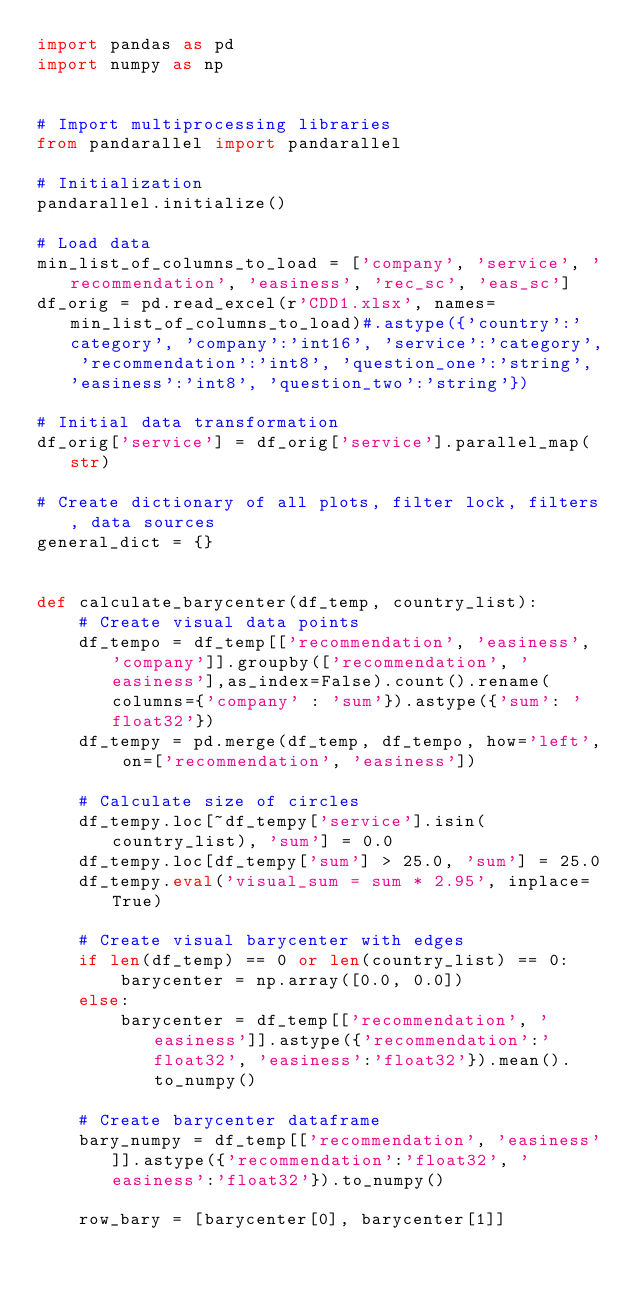Convert code to text. <code><loc_0><loc_0><loc_500><loc_500><_Python_>import pandas as pd
import numpy as np


# Import multiprocessing libraries
from pandarallel import pandarallel

# Initialization
pandarallel.initialize()

# Load data
min_list_of_columns_to_load = ['company', 'service', 'recommendation', 'easiness', 'rec_sc', 'eas_sc']
df_orig = pd.read_excel(r'CDD1.xlsx', names=min_list_of_columns_to_load)#.astype({'country':'category', 'company':'int16', 'service':'category', 'recommendation':'int8', 'question_one':'string', 'easiness':'int8', 'question_two':'string'})

# Initial data transformation
df_orig['service'] = df_orig['service'].parallel_map(str)

# Create dictionary of all plots, filter lock, filters, data sources
general_dict = {}


def calculate_barycenter(df_temp, country_list):   
    # Create visual data points
    df_tempo = df_temp[['recommendation', 'easiness', 'company']].groupby(['recommendation', 'easiness'],as_index=False).count().rename(columns={'company' : 'sum'}).astype({'sum': 'float32'})
    df_tempy = pd.merge(df_temp, df_tempo, how='left', on=['recommendation', 'easiness'])

    # Calculate size of circles
    df_tempy.loc[~df_tempy['service'].isin(country_list), 'sum'] = 0.0
    df_tempy.loc[df_tempy['sum'] > 25.0, 'sum'] = 25.0
    df_tempy.eval('visual_sum = sum * 2.95', inplace=True)

    # Create visual barycenter with edges
    if len(df_temp) == 0 or len(country_list) == 0:
        barycenter = np.array([0.0, 0.0])
    else:
        barycenter = df_temp[['recommendation', 'easiness']].astype({'recommendation':'float32', 'easiness':'float32'}).mean().to_numpy()
    
    # Create barycenter dataframe
    bary_numpy = df_temp[['recommendation', 'easiness']].astype({'recommendation':'float32', 'easiness':'float32'}).to_numpy()

    row_bary = [barycenter[0], barycenter[1]]</code> 